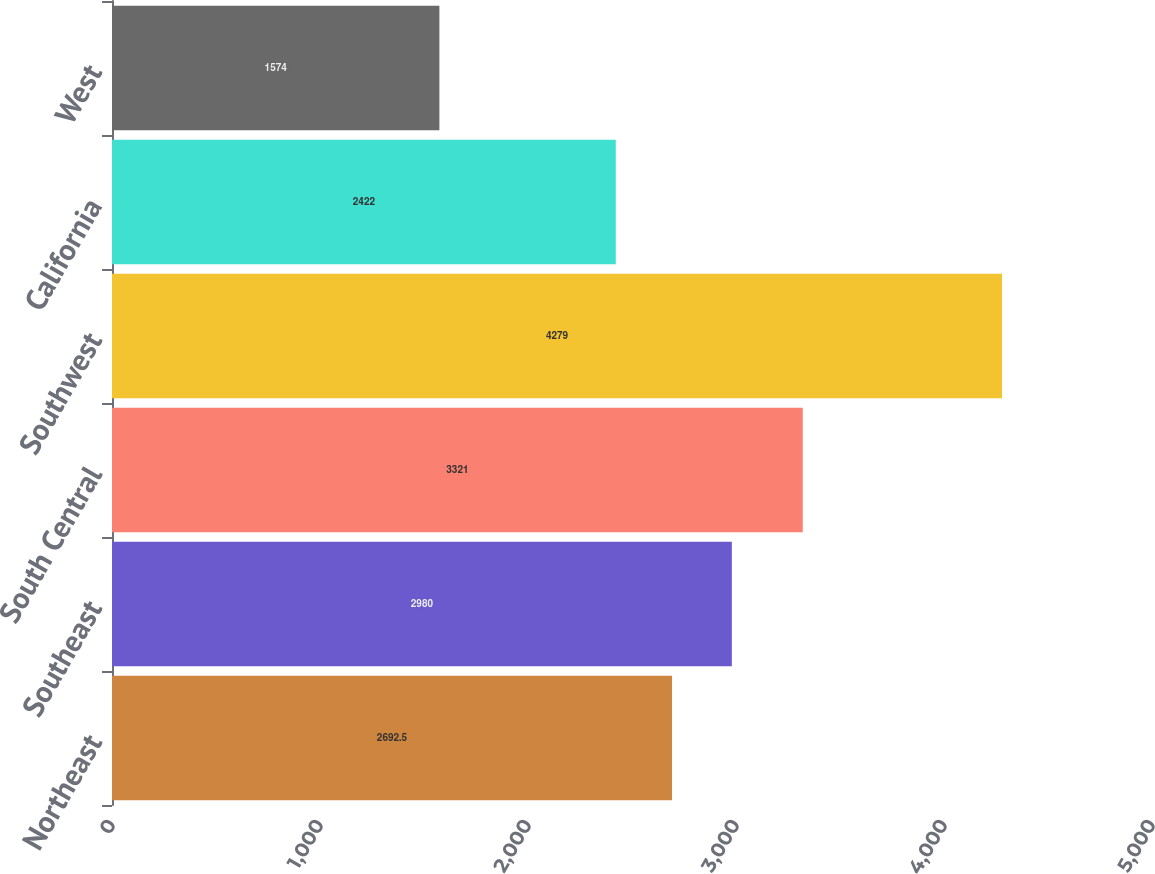<chart> <loc_0><loc_0><loc_500><loc_500><bar_chart><fcel>Northeast<fcel>Southeast<fcel>South Central<fcel>Southwest<fcel>California<fcel>West<nl><fcel>2692.5<fcel>2980<fcel>3321<fcel>4279<fcel>2422<fcel>1574<nl></chart> 